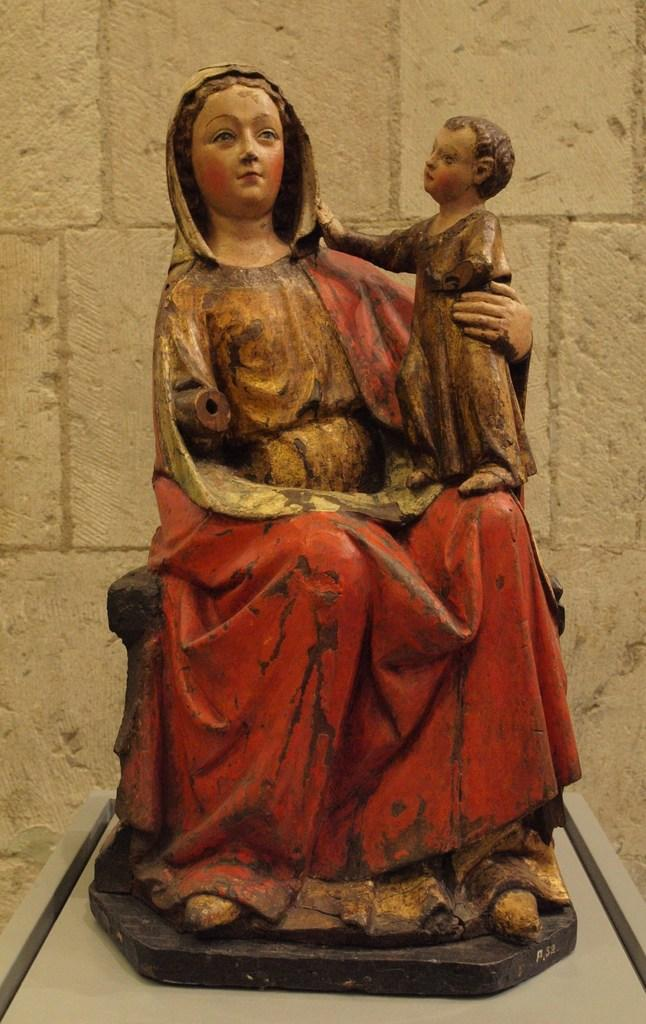What is the main subject of the image? There is a statue of a lady in the image. What is the lady holding in her hand? The lady is holding a baby in her hand. What is the lady sitting on? The lady is sitting on something, but the specific object is not mentioned in the facts. What can be seen behind the statue? There is a stone wall behind the statue. What time of day is it in the image? The time of day is not mentioned in the facts, so it cannot be determined from the image. How many girls are present in the image? There is no mention of a girl in the facts, so it cannot be determined from the image. 